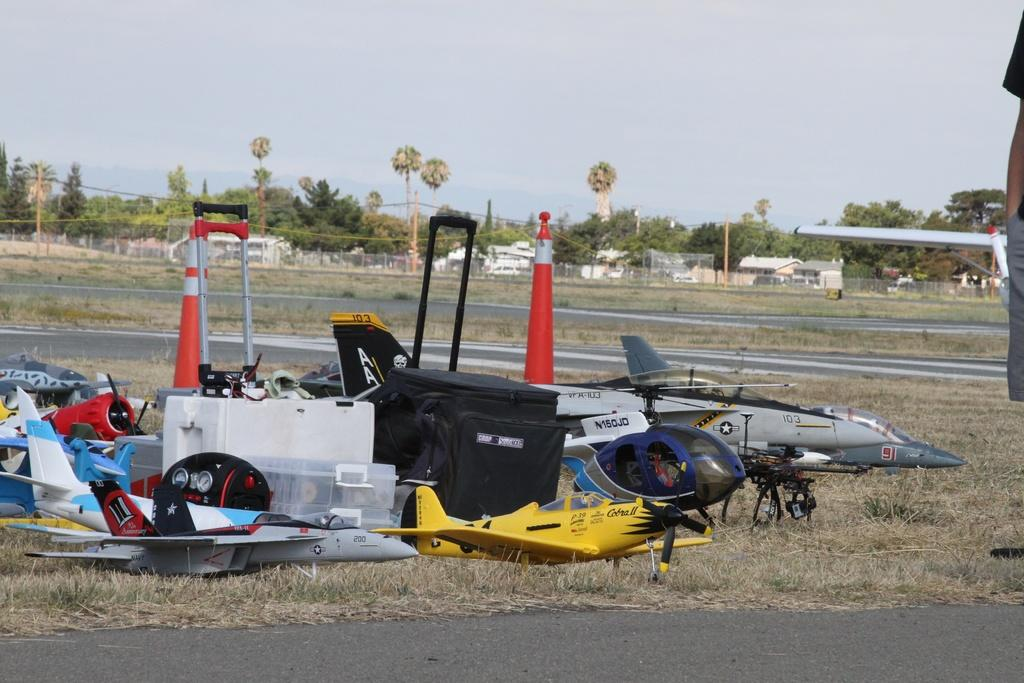<image>
Write a terse but informative summary of the picture. the yellow plane sitting with the rest is called the Cobra II 